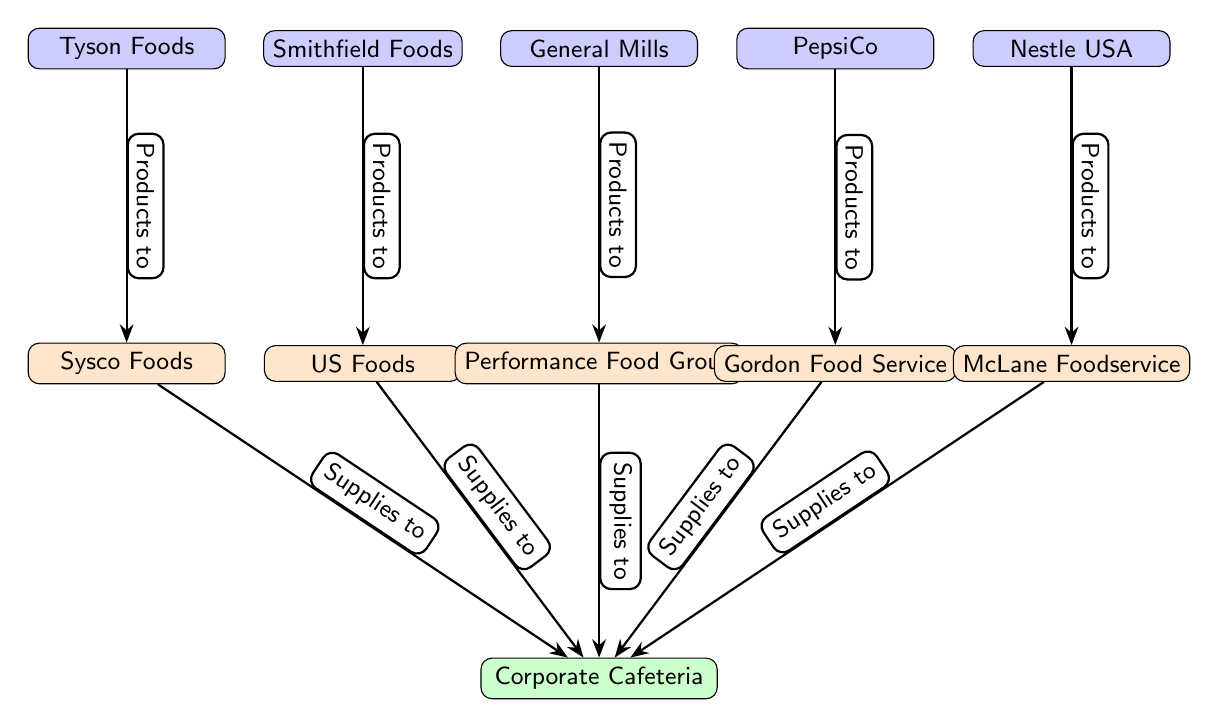What is the main purpose of the Corporate Cafeteria? The Corporate Cafeteria is at the center of the diagram and receives supplies from various suppliers, indicating its role in food services.
Answer: Food services How many wholesale food suppliers are there? Counting the supplier nodes in the diagram, there are five suppliers indicated.
Answer: 5 Which manufacturer provides products to Sysco Foods? To answer this, we trace the edge leading from manufacturers to the supplier Sysco Foods and find that Tyson Foods is connected to Sysco Foods.
Answer: Tyson Foods What type of products do the suppliers provide to the Corporate Cafeteria? The arrows labeled "Supplies to" indicate the direction of supply from the suppliers to the cafeteria. Based on this, the suppliers provide food products.
Answer: Food products Which supplier has the most manufacturers connected to it? To determine this, we check each supplier's connections from manufacturers, and find that all suppliers have a single connection; hence, no supplier has multiple manufacturers connected.
Answer: None What is the relationship between Performance Food Group and the Corporate Cafeteria? The edge labeled "Supplies to" indicates that Performance Food Group supplies products directly to the Corporate Cafeteria.
Answer: Supplies to How many manufacturers are listed in the diagram? By counting all the manufacturer nodes, we find that there are five manufacturers included in the diagram.
Answer: 5 Identify the supplier that McLane Foodservice receives products from. Tracing the arrows in the diagram, McLane Foodservice is the supplier, and so there are no manufacturers providing products to others as it only connects to the cafeteria.
Answer: None 